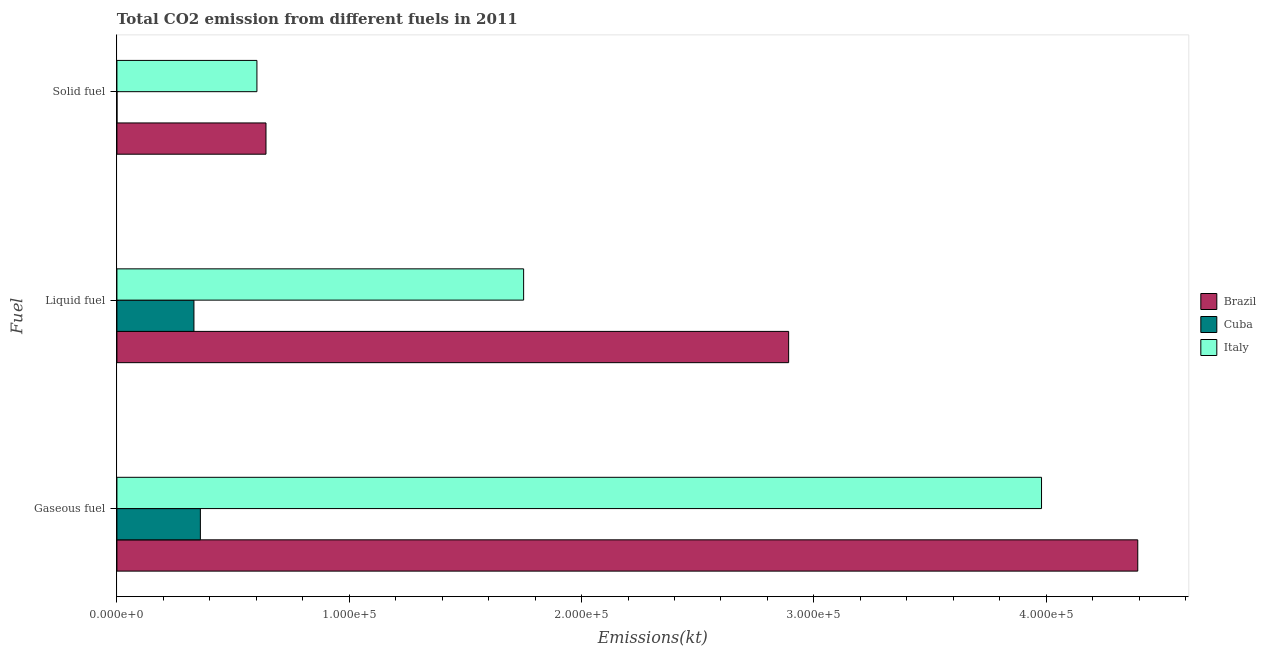Are the number of bars per tick equal to the number of legend labels?
Provide a short and direct response. Yes. Are the number of bars on each tick of the Y-axis equal?
Give a very brief answer. Yes. What is the label of the 2nd group of bars from the top?
Give a very brief answer. Liquid fuel. What is the amount of co2 emissions from liquid fuel in Italy?
Your answer should be compact. 1.75e+05. Across all countries, what is the maximum amount of co2 emissions from gaseous fuel?
Make the answer very short. 4.39e+05. Across all countries, what is the minimum amount of co2 emissions from liquid fuel?
Ensure brevity in your answer.  3.31e+04. In which country was the amount of co2 emissions from gaseous fuel maximum?
Offer a very short reply. Brazil. In which country was the amount of co2 emissions from gaseous fuel minimum?
Give a very brief answer. Cuba. What is the total amount of co2 emissions from solid fuel in the graph?
Ensure brevity in your answer.  1.24e+05. What is the difference between the amount of co2 emissions from gaseous fuel in Italy and that in Brazil?
Your answer should be very brief. -4.14e+04. What is the difference between the amount of co2 emissions from gaseous fuel in Cuba and the amount of co2 emissions from liquid fuel in Italy?
Make the answer very short. -1.39e+05. What is the average amount of co2 emissions from gaseous fuel per country?
Provide a short and direct response. 2.91e+05. What is the difference between the amount of co2 emissions from solid fuel and amount of co2 emissions from gaseous fuel in Brazil?
Offer a very short reply. -3.75e+05. What is the ratio of the amount of co2 emissions from liquid fuel in Cuba to that in Italy?
Ensure brevity in your answer.  0.19. Is the difference between the amount of co2 emissions from gaseous fuel in Brazil and Italy greater than the difference between the amount of co2 emissions from solid fuel in Brazil and Italy?
Your answer should be very brief. Yes. What is the difference between the highest and the second highest amount of co2 emissions from liquid fuel?
Provide a succinct answer. 1.14e+05. What is the difference between the highest and the lowest amount of co2 emissions from solid fuel?
Provide a succinct answer. 6.42e+04. In how many countries, is the amount of co2 emissions from liquid fuel greater than the average amount of co2 emissions from liquid fuel taken over all countries?
Provide a succinct answer. 2. Is the sum of the amount of co2 emissions from liquid fuel in Brazil and Italy greater than the maximum amount of co2 emissions from solid fuel across all countries?
Your response must be concise. Yes. What does the 2nd bar from the top in Solid fuel represents?
Make the answer very short. Cuba. What does the 2nd bar from the bottom in Gaseous fuel represents?
Offer a terse response. Cuba. Is it the case that in every country, the sum of the amount of co2 emissions from gaseous fuel and amount of co2 emissions from liquid fuel is greater than the amount of co2 emissions from solid fuel?
Ensure brevity in your answer.  Yes. How many bars are there?
Provide a short and direct response. 9. How many countries are there in the graph?
Your answer should be very brief. 3. Are the values on the major ticks of X-axis written in scientific E-notation?
Provide a succinct answer. Yes. What is the title of the graph?
Provide a short and direct response. Total CO2 emission from different fuels in 2011. What is the label or title of the X-axis?
Ensure brevity in your answer.  Emissions(kt). What is the label or title of the Y-axis?
Make the answer very short. Fuel. What is the Emissions(kt) of Brazil in Gaseous fuel?
Offer a very short reply. 4.39e+05. What is the Emissions(kt) of Cuba in Gaseous fuel?
Offer a very short reply. 3.59e+04. What is the Emissions(kt) of Italy in Gaseous fuel?
Your answer should be very brief. 3.98e+05. What is the Emissions(kt) in Brazil in Liquid fuel?
Offer a very short reply. 2.89e+05. What is the Emissions(kt) of Cuba in Liquid fuel?
Your response must be concise. 3.31e+04. What is the Emissions(kt) in Italy in Liquid fuel?
Your response must be concise. 1.75e+05. What is the Emissions(kt) of Brazil in Solid fuel?
Give a very brief answer. 6.42e+04. What is the Emissions(kt) of Cuba in Solid fuel?
Make the answer very short. 11. What is the Emissions(kt) in Italy in Solid fuel?
Offer a very short reply. 6.03e+04. Across all Fuel, what is the maximum Emissions(kt) of Brazil?
Keep it short and to the point. 4.39e+05. Across all Fuel, what is the maximum Emissions(kt) in Cuba?
Offer a terse response. 3.59e+04. Across all Fuel, what is the maximum Emissions(kt) in Italy?
Offer a very short reply. 3.98e+05. Across all Fuel, what is the minimum Emissions(kt) in Brazil?
Make the answer very short. 6.42e+04. Across all Fuel, what is the minimum Emissions(kt) in Cuba?
Offer a terse response. 11. Across all Fuel, what is the minimum Emissions(kt) of Italy?
Provide a short and direct response. 6.03e+04. What is the total Emissions(kt) in Brazil in the graph?
Offer a very short reply. 7.93e+05. What is the total Emissions(kt) in Cuba in the graph?
Give a very brief answer. 6.91e+04. What is the total Emissions(kt) of Italy in the graph?
Make the answer very short. 6.33e+05. What is the difference between the Emissions(kt) in Brazil in Gaseous fuel and that in Liquid fuel?
Offer a very short reply. 1.50e+05. What is the difference between the Emissions(kt) in Cuba in Gaseous fuel and that in Liquid fuel?
Make the answer very short. 2772.25. What is the difference between the Emissions(kt) in Italy in Gaseous fuel and that in Liquid fuel?
Give a very brief answer. 2.23e+05. What is the difference between the Emissions(kt) in Brazil in Gaseous fuel and that in Solid fuel?
Give a very brief answer. 3.75e+05. What is the difference between the Emissions(kt) in Cuba in Gaseous fuel and that in Solid fuel?
Offer a very short reply. 3.59e+04. What is the difference between the Emissions(kt) of Italy in Gaseous fuel and that in Solid fuel?
Keep it short and to the point. 3.38e+05. What is the difference between the Emissions(kt) in Brazil in Liquid fuel and that in Solid fuel?
Your answer should be compact. 2.25e+05. What is the difference between the Emissions(kt) in Cuba in Liquid fuel and that in Solid fuel?
Give a very brief answer. 3.31e+04. What is the difference between the Emissions(kt) in Italy in Liquid fuel and that in Solid fuel?
Make the answer very short. 1.15e+05. What is the difference between the Emissions(kt) in Brazil in Gaseous fuel and the Emissions(kt) in Cuba in Liquid fuel?
Ensure brevity in your answer.  4.06e+05. What is the difference between the Emissions(kt) of Brazil in Gaseous fuel and the Emissions(kt) of Italy in Liquid fuel?
Provide a succinct answer. 2.64e+05. What is the difference between the Emissions(kt) in Cuba in Gaseous fuel and the Emissions(kt) in Italy in Liquid fuel?
Keep it short and to the point. -1.39e+05. What is the difference between the Emissions(kt) of Brazil in Gaseous fuel and the Emissions(kt) of Cuba in Solid fuel?
Ensure brevity in your answer.  4.39e+05. What is the difference between the Emissions(kt) in Brazil in Gaseous fuel and the Emissions(kt) in Italy in Solid fuel?
Provide a short and direct response. 3.79e+05. What is the difference between the Emissions(kt) in Cuba in Gaseous fuel and the Emissions(kt) in Italy in Solid fuel?
Your response must be concise. -2.43e+04. What is the difference between the Emissions(kt) in Brazil in Liquid fuel and the Emissions(kt) in Cuba in Solid fuel?
Your answer should be very brief. 2.89e+05. What is the difference between the Emissions(kt) of Brazil in Liquid fuel and the Emissions(kt) of Italy in Solid fuel?
Provide a short and direct response. 2.29e+05. What is the difference between the Emissions(kt) of Cuba in Liquid fuel and the Emissions(kt) of Italy in Solid fuel?
Keep it short and to the point. -2.71e+04. What is the average Emissions(kt) in Brazil per Fuel?
Make the answer very short. 2.64e+05. What is the average Emissions(kt) in Cuba per Fuel?
Your answer should be very brief. 2.30e+04. What is the average Emissions(kt) in Italy per Fuel?
Offer a terse response. 2.11e+05. What is the difference between the Emissions(kt) of Brazil and Emissions(kt) of Cuba in Gaseous fuel?
Ensure brevity in your answer.  4.03e+05. What is the difference between the Emissions(kt) of Brazil and Emissions(kt) of Italy in Gaseous fuel?
Offer a terse response. 4.14e+04. What is the difference between the Emissions(kt) of Cuba and Emissions(kt) of Italy in Gaseous fuel?
Your response must be concise. -3.62e+05. What is the difference between the Emissions(kt) in Brazil and Emissions(kt) in Cuba in Liquid fuel?
Keep it short and to the point. 2.56e+05. What is the difference between the Emissions(kt) of Brazil and Emissions(kt) of Italy in Liquid fuel?
Give a very brief answer. 1.14e+05. What is the difference between the Emissions(kt) in Cuba and Emissions(kt) in Italy in Liquid fuel?
Give a very brief answer. -1.42e+05. What is the difference between the Emissions(kt) in Brazil and Emissions(kt) in Cuba in Solid fuel?
Provide a short and direct response. 6.42e+04. What is the difference between the Emissions(kt) of Brazil and Emissions(kt) of Italy in Solid fuel?
Your answer should be very brief. 3905.36. What is the difference between the Emissions(kt) in Cuba and Emissions(kt) in Italy in Solid fuel?
Offer a very short reply. -6.02e+04. What is the ratio of the Emissions(kt) in Brazil in Gaseous fuel to that in Liquid fuel?
Offer a terse response. 1.52. What is the ratio of the Emissions(kt) in Cuba in Gaseous fuel to that in Liquid fuel?
Your answer should be very brief. 1.08. What is the ratio of the Emissions(kt) in Italy in Gaseous fuel to that in Liquid fuel?
Offer a very short reply. 2.27. What is the ratio of the Emissions(kt) of Brazil in Gaseous fuel to that in Solid fuel?
Offer a terse response. 6.85. What is the ratio of the Emissions(kt) of Cuba in Gaseous fuel to that in Solid fuel?
Offer a very short reply. 3265.33. What is the ratio of the Emissions(kt) of Italy in Gaseous fuel to that in Solid fuel?
Keep it short and to the point. 6.6. What is the ratio of the Emissions(kt) in Brazil in Liquid fuel to that in Solid fuel?
Offer a terse response. 4.51. What is the ratio of the Emissions(kt) of Cuba in Liquid fuel to that in Solid fuel?
Make the answer very short. 3013.33. What is the ratio of the Emissions(kt) in Italy in Liquid fuel to that in Solid fuel?
Offer a very short reply. 2.91. What is the difference between the highest and the second highest Emissions(kt) of Brazil?
Your response must be concise. 1.50e+05. What is the difference between the highest and the second highest Emissions(kt) in Cuba?
Make the answer very short. 2772.25. What is the difference between the highest and the second highest Emissions(kt) of Italy?
Offer a terse response. 2.23e+05. What is the difference between the highest and the lowest Emissions(kt) in Brazil?
Keep it short and to the point. 3.75e+05. What is the difference between the highest and the lowest Emissions(kt) of Cuba?
Your response must be concise. 3.59e+04. What is the difference between the highest and the lowest Emissions(kt) of Italy?
Provide a succinct answer. 3.38e+05. 